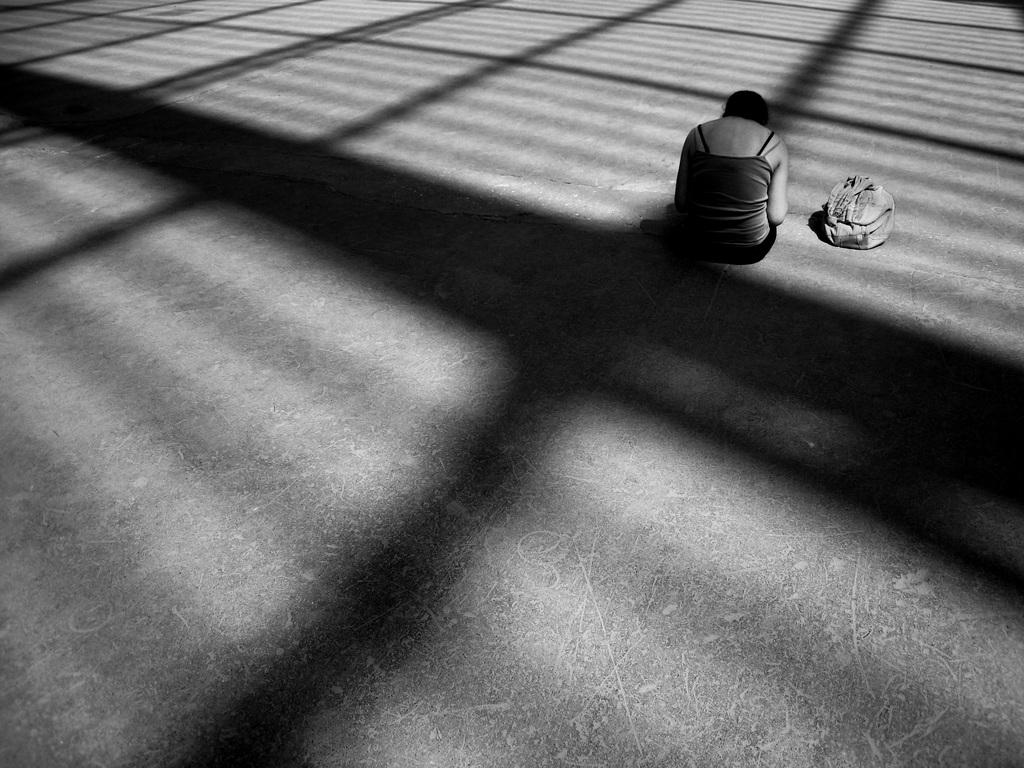What is the color scheme of the image? The image is black and white. What can be seen in the image? There is a person sitting in the image. On what surface is the person sitting? The person is sitting on a surface. What is located beside the person? There is a bag beside the person. What else can be observed in the image? Shadows of objects are visible in the image. What type of glove is the person wearing in the image? There is no glove visible in the image; the person is not wearing any gloves. What book is the person reading in the image? There is no book present in the image, and the person is not reading anything. 